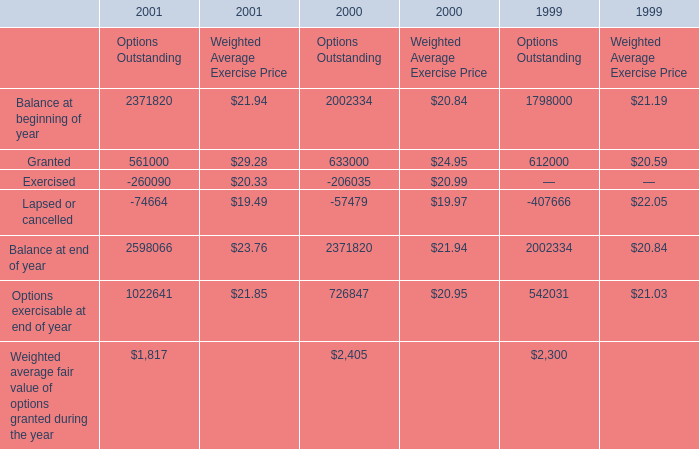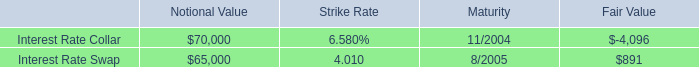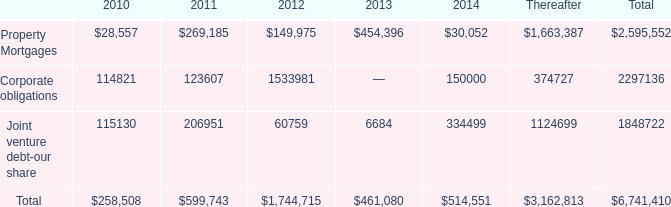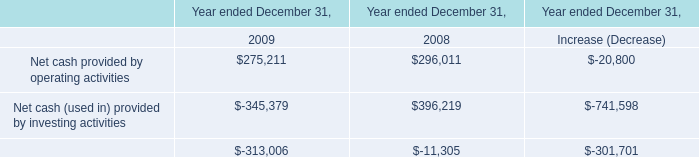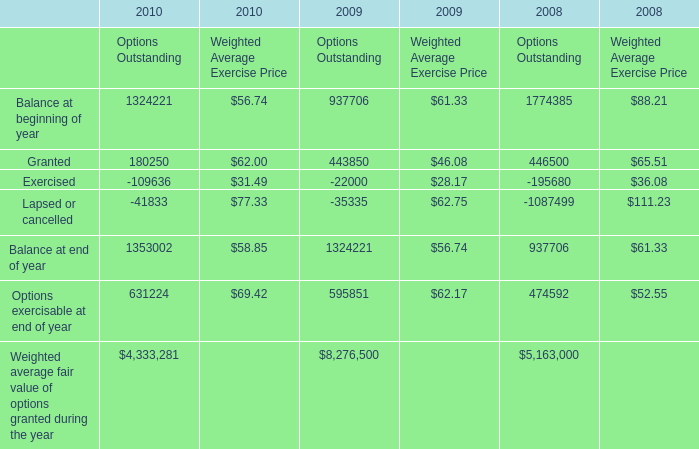What's the average of Granted of 2008 Options Outstanding, and Balance at end of year of 2000 Options Outstanding ? 
Computations: ((446500.0 + 2371820.0) / 2)
Answer: 1409160.0. 